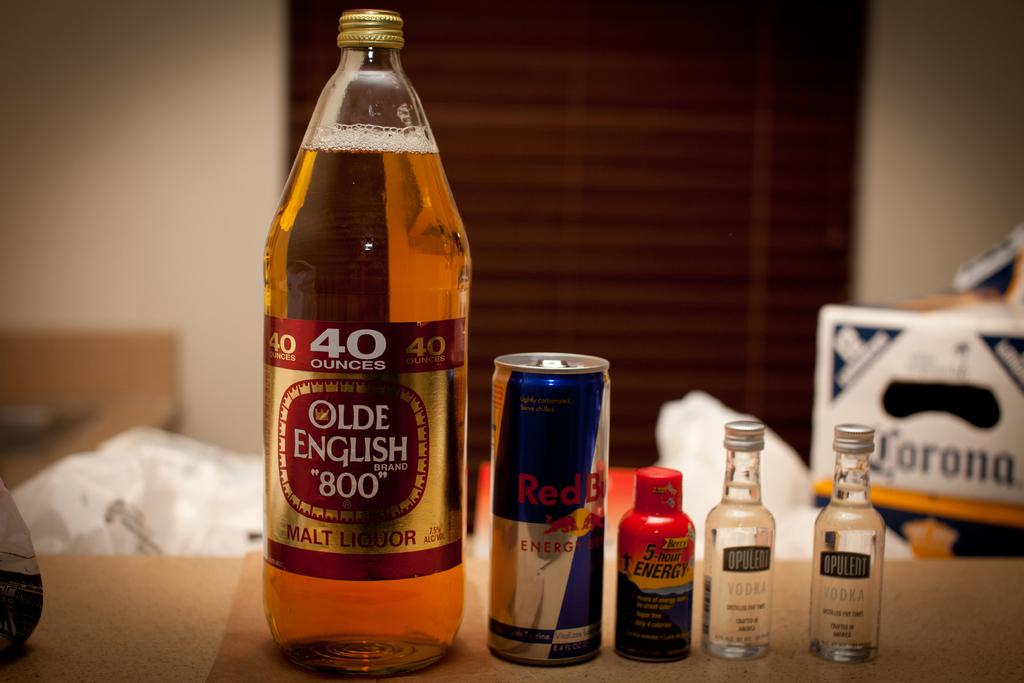Provide a one-sentence caption for the provided image. A 40 oz Olde English sits next to a Red Bull and other drinks on a table. 